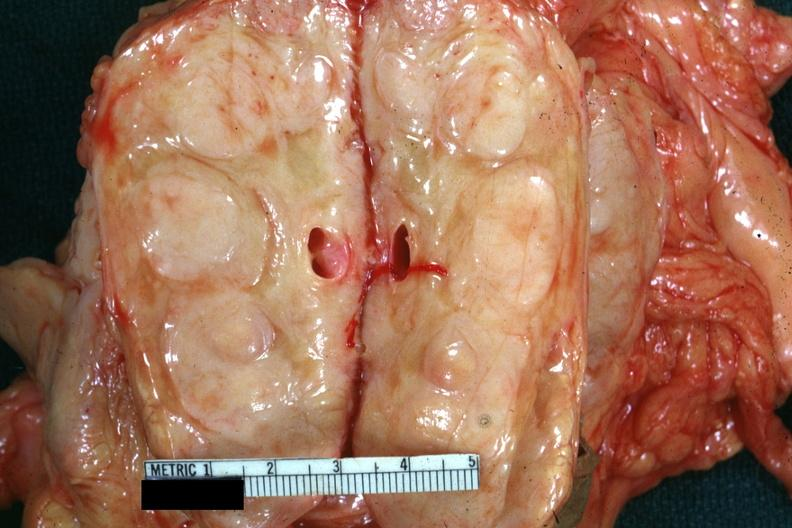what is cut edge of mesentery showing?
Answer the question using a single word or phrase. Massively enlarged nodes very good example was diagnosed as reticulum cell sarcoma 